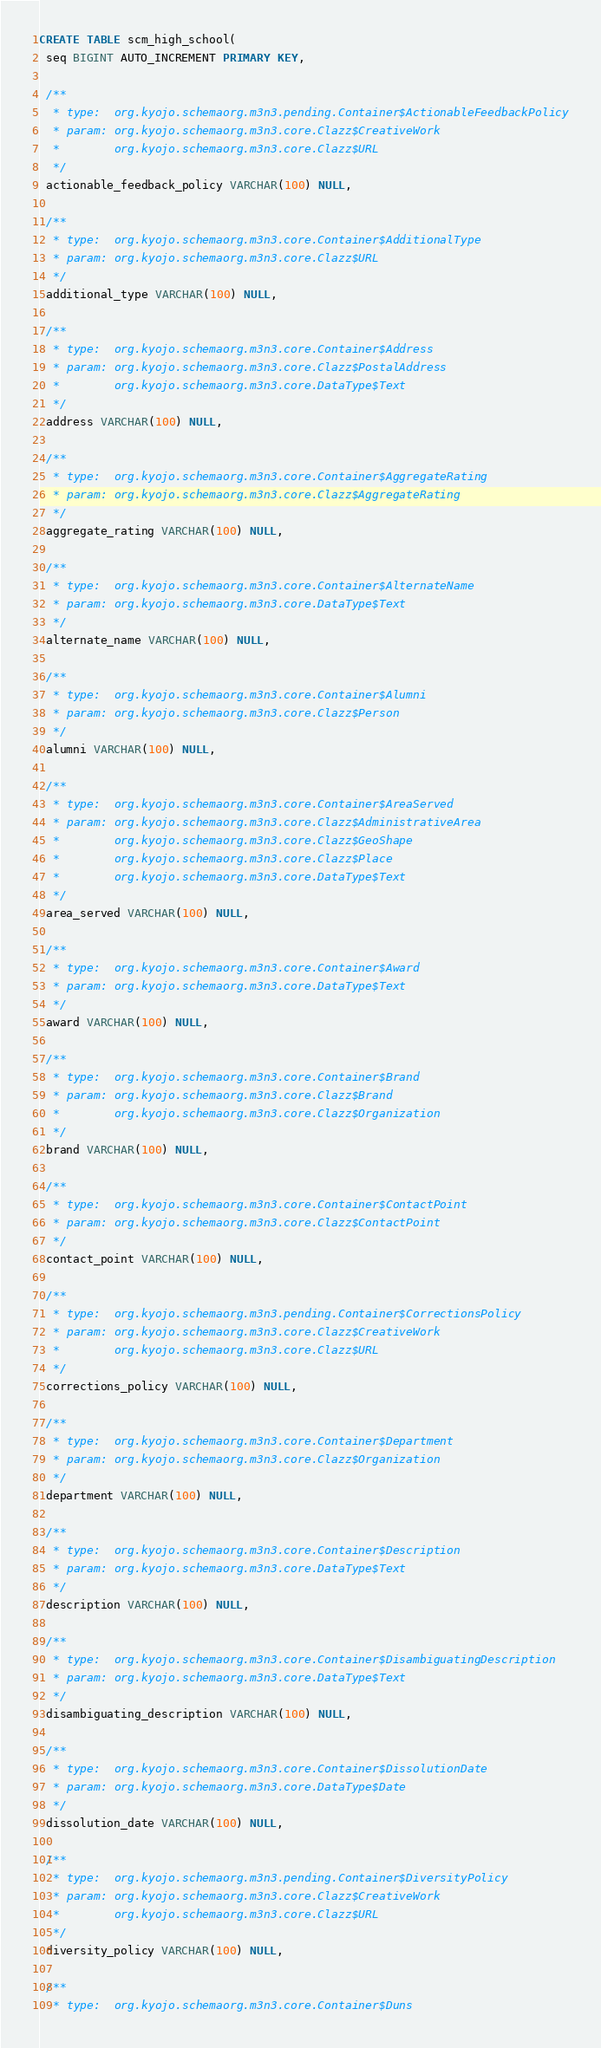<code> <loc_0><loc_0><loc_500><loc_500><_SQL_>CREATE TABLE scm_high_school(
 seq BIGINT AUTO_INCREMENT PRIMARY KEY,

 /**
  * type:  org.kyojo.schemaorg.m3n3.pending.Container$ActionableFeedbackPolicy
  * param: org.kyojo.schemaorg.m3n3.core.Clazz$CreativeWork
  *        org.kyojo.schemaorg.m3n3.core.Clazz$URL
  */
 actionable_feedback_policy VARCHAR(100) NULL,

 /**
  * type:  org.kyojo.schemaorg.m3n3.core.Container$AdditionalType
  * param: org.kyojo.schemaorg.m3n3.core.Clazz$URL
  */
 additional_type VARCHAR(100) NULL,

 /**
  * type:  org.kyojo.schemaorg.m3n3.core.Container$Address
  * param: org.kyojo.schemaorg.m3n3.core.Clazz$PostalAddress
  *        org.kyojo.schemaorg.m3n3.core.DataType$Text
  */
 address VARCHAR(100) NULL,

 /**
  * type:  org.kyojo.schemaorg.m3n3.core.Container$AggregateRating
  * param: org.kyojo.schemaorg.m3n3.core.Clazz$AggregateRating
  */
 aggregate_rating VARCHAR(100) NULL,

 /**
  * type:  org.kyojo.schemaorg.m3n3.core.Container$AlternateName
  * param: org.kyojo.schemaorg.m3n3.core.DataType$Text
  */
 alternate_name VARCHAR(100) NULL,

 /**
  * type:  org.kyojo.schemaorg.m3n3.core.Container$Alumni
  * param: org.kyojo.schemaorg.m3n3.core.Clazz$Person
  */
 alumni VARCHAR(100) NULL,

 /**
  * type:  org.kyojo.schemaorg.m3n3.core.Container$AreaServed
  * param: org.kyojo.schemaorg.m3n3.core.Clazz$AdministrativeArea
  *        org.kyojo.schemaorg.m3n3.core.Clazz$GeoShape
  *        org.kyojo.schemaorg.m3n3.core.Clazz$Place
  *        org.kyojo.schemaorg.m3n3.core.DataType$Text
  */
 area_served VARCHAR(100) NULL,

 /**
  * type:  org.kyojo.schemaorg.m3n3.core.Container$Award
  * param: org.kyojo.schemaorg.m3n3.core.DataType$Text
  */
 award VARCHAR(100) NULL,

 /**
  * type:  org.kyojo.schemaorg.m3n3.core.Container$Brand
  * param: org.kyojo.schemaorg.m3n3.core.Clazz$Brand
  *        org.kyojo.schemaorg.m3n3.core.Clazz$Organization
  */
 brand VARCHAR(100) NULL,

 /**
  * type:  org.kyojo.schemaorg.m3n3.core.Container$ContactPoint
  * param: org.kyojo.schemaorg.m3n3.core.Clazz$ContactPoint
  */
 contact_point VARCHAR(100) NULL,

 /**
  * type:  org.kyojo.schemaorg.m3n3.pending.Container$CorrectionsPolicy
  * param: org.kyojo.schemaorg.m3n3.core.Clazz$CreativeWork
  *        org.kyojo.schemaorg.m3n3.core.Clazz$URL
  */
 corrections_policy VARCHAR(100) NULL,

 /**
  * type:  org.kyojo.schemaorg.m3n3.core.Container$Department
  * param: org.kyojo.schemaorg.m3n3.core.Clazz$Organization
  */
 department VARCHAR(100) NULL,

 /**
  * type:  org.kyojo.schemaorg.m3n3.core.Container$Description
  * param: org.kyojo.schemaorg.m3n3.core.DataType$Text
  */
 description VARCHAR(100) NULL,

 /**
  * type:  org.kyojo.schemaorg.m3n3.core.Container$DisambiguatingDescription
  * param: org.kyojo.schemaorg.m3n3.core.DataType$Text
  */
 disambiguating_description VARCHAR(100) NULL,

 /**
  * type:  org.kyojo.schemaorg.m3n3.core.Container$DissolutionDate
  * param: org.kyojo.schemaorg.m3n3.core.DataType$Date
  */
 dissolution_date VARCHAR(100) NULL,

 /**
  * type:  org.kyojo.schemaorg.m3n3.pending.Container$DiversityPolicy
  * param: org.kyojo.schemaorg.m3n3.core.Clazz$CreativeWork
  *        org.kyojo.schemaorg.m3n3.core.Clazz$URL
  */
 diversity_policy VARCHAR(100) NULL,

 /**
  * type:  org.kyojo.schemaorg.m3n3.core.Container$Duns</code> 